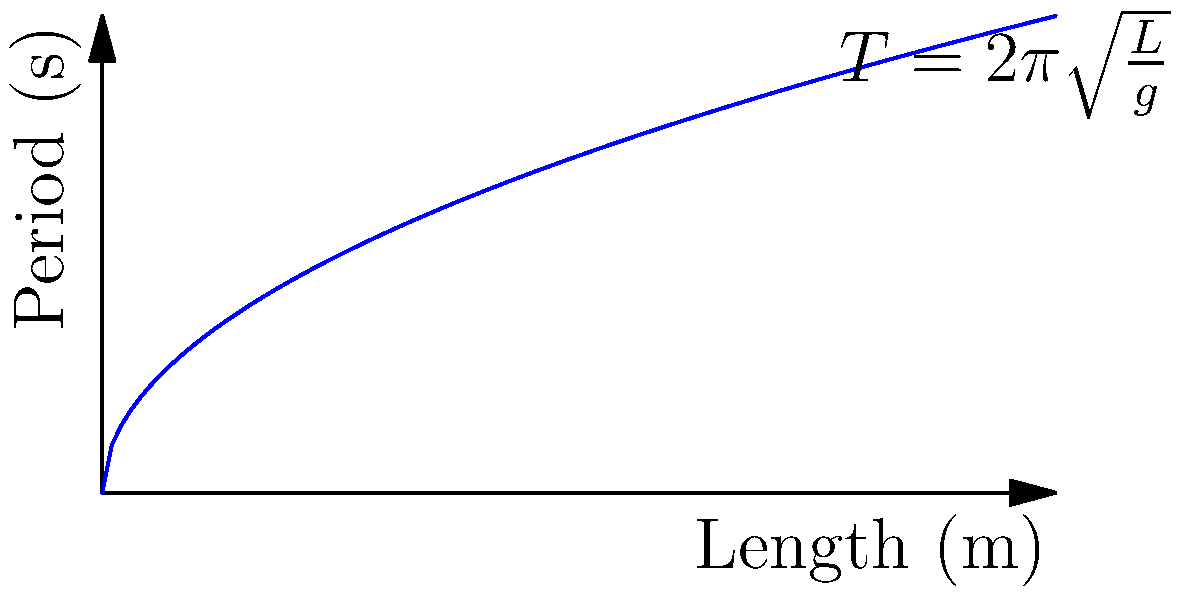A simple pendulum's period is given by the equation $T = 2\pi\sqrt{\frac{L}{g}}$, where $T$ is the period, $L$ is the length of the pendulum, and $g$ is the acceleration due to gravity. If you double the length of a pendulum, how does its period change? Explain your reasoning using the graph provided. To understand how doubling the length affects the period, let's follow these steps:

1. Observe the equation: $T = 2\pi\sqrt{\frac{L}{g}}$

2. Note that $g$ (acceleration due to gravity) is constant.

3. The graph shows the relationship between length (x-axis) and period (y-axis).

4. The curve is not linear but follows a square root function.

5. To double the length, we multiply $L$ by 2:
   $T_{new} = 2\pi\sqrt{\frac{2L}{g}}$

6. Factor out the 2:
   $T_{new} = 2\pi\sqrt{2}\sqrt{\frac{L}{g}}$

7. Recognize the original period in this equation:
   $T_{new} = \sqrt{2} \cdot 2\pi\sqrt{\frac{L}{g}} = \sqrt{2} \cdot T_{original}$

8. $\sqrt{2} \approx 1.414$

Therefore, doubling the length increases the period by a factor of $\sqrt{2}$, or approximately 1.414 times the original period.

This can be visually confirmed on the graph: when you double the x-value (length), the y-value (period) increases but not by double - it's a smaller increase, consistent with the $\sqrt{2}$ factor.
Answer: The period increases by a factor of $\sqrt{2}$ (approximately 1.414 times). 